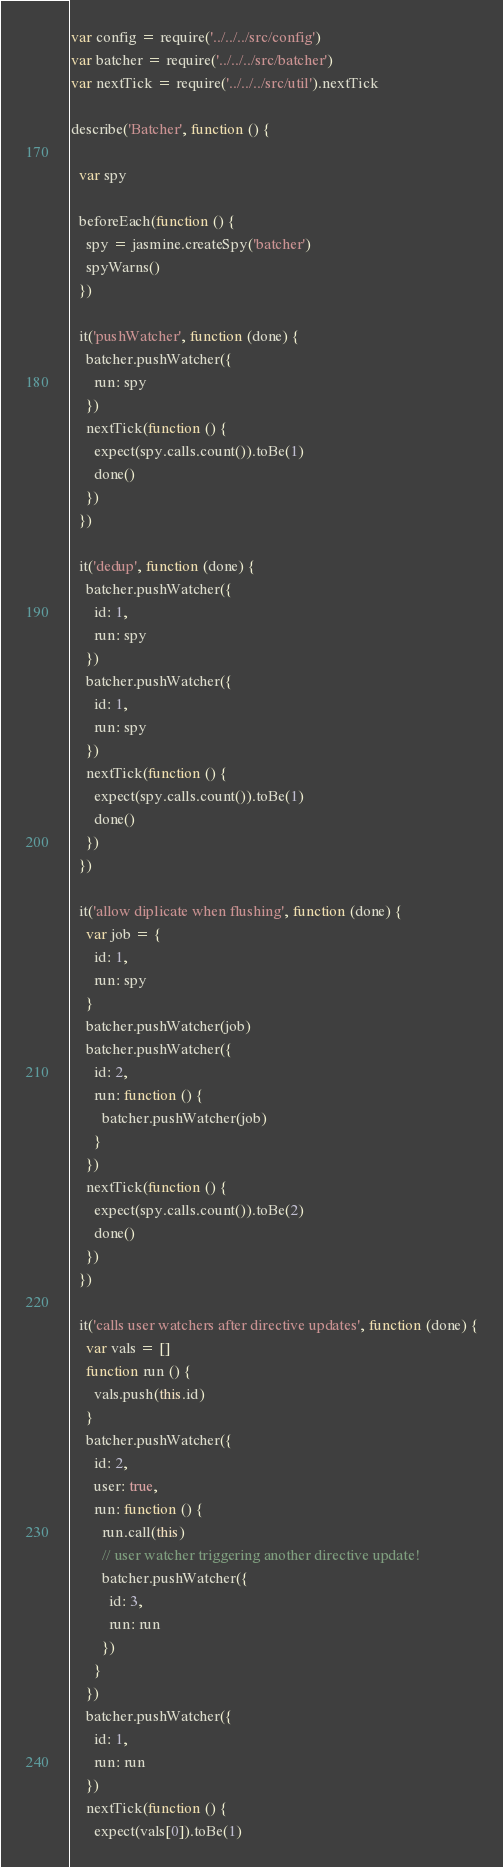Convert code to text. <code><loc_0><loc_0><loc_500><loc_500><_JavaScript_>var config = require('../../../src/config')
var batcher = require('../../../src/batcher')
var nextTick = require('../../../src/util').nextTick

describe('Batcher', function () {

  var spy

  beforeEach(function () {
    spy = jasmine.createSpy('batcher')
    spyWarns()
  })

  it('pushWatcher', function (done) {
    batcher.pushWatcher({
      run: spy
    })
    nextTick(function () {
      expect(spy.calls.count()).toBe(1)
      done()
    })
  })

  it('dedup', function (done) {
    batcher.pushWatcher({
      id: 1,
      run: spy
    })
    batcher.pushWatcher({
      id: 1,
      run: spy
    })
    nextTick(function () {
      expect(spy.calls.count()).toBe(1)
      done()
    })
  })

  it('allow diplicate when flushing', function (done) {
    var job = {
      id: 1,
      run: spy
    }
    batcher.pushWatcher(job)
    batcher.pushWatcher({
      id: 2,
      run: function () {
        batcher.pushWatcher(job)
      }
    })
    nextTick(function () {
      expect(spy.calls.count()).toBe(2)
      done()
    })
  })

  it('calls user watchers after directive updates', function (done) {
    var vals = []
    function run () {
      vals.push(this.id)
    }
    batcher.pushWatcher({
      id: 2,
      user: true,
      run: function () {
        run.call(this)
        // user watcher triggering another directive update!
        batcher.pushWatcher({
          id: 3,
          run: run
        })
      }
    })
    batcher.pushWatcher({
      id: 1,
      run: run
    })
    nextTick(function () {
      expect(vals[0]).toBe(1)</code> 